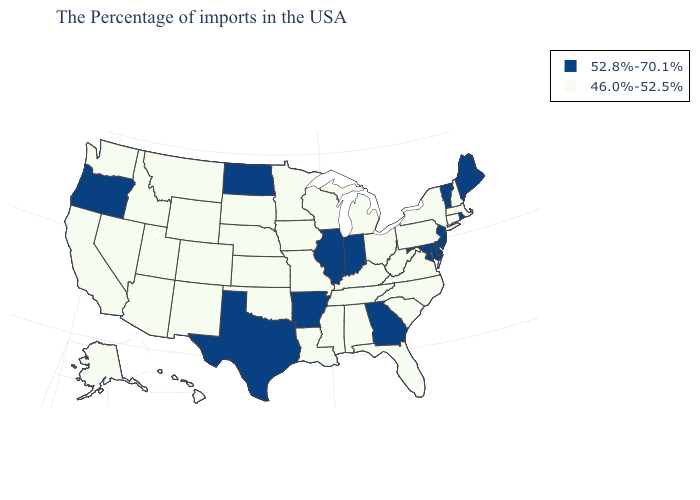Does Illinois have the highest value in the MidWest?
Give a very brief answer. Yes. Does Oregon have the lowest value in the West?
Give a very brief answer. No. Does Illinois have the highest value in the MidWest?
Be succinct. Yes. Among the states that border Connecticut , does Massachusetts have the lowest value?
Give a very brief answer. Yes. What is the value of New Hampshire?
Keep it brief. 46.0%-52.5%. Name the states that have a value in the range 46.0%-52.5%?
Write a very short answer. Massachusetts, New Hampshire, Connecticut, New York, Pennsylvania, Virginia, North Carolina, South Carolina, West Virginia, Ohio, Florida, Michigan, Kentucky, Alabama, Tennessee, Wisconsin, Mississippi, Louisiana, Missouri, Minnesota, Iowa, Kansas, Nebraska, Oklahoma, South Dakota, Wyoming, Colorado, New Mexico, Utah, Montana, Arizona, Idaho, Nevada, California, Washington, Alaska, Hawaii. Name the states that have a value in the range 46.0%-52.5%?
Quick response, please. Massachusetts, New Hampshire, Connecticut, New York, Pennsylvania, Virginia, North Carolina, South Carolina, West Virginia, Ohio, Florida, Michigan, Kentucky, Alabama, Tennessee, Wisconsin, Mississippi, Louisiana, Missouri, Minnesota, Iowa, Kansas, Nebraska, Oklahoma, South Dakota, Wyoming, Colorado, New Mexico, Utah, Montana, Arizona, Idaho, Nevada, California, Washington, Alaska, Hawaii. Name the states that have a value in the range 52.8%-70.1%?
Short answer required. Maine, Rhode Island, Vermont, New Jersey, Delaware, Maryland, Georgia, Indiana, Illinois, Arkansas, Texas, North Dakota, Oregon. Name the states that have a value in the range 46.0%-52.5%?
Give a very brief answer. Massachusetts, New Hampshire, Connecticut, New York, Pennsylvania, Virginia, North Carolina, South Carolina, West Virginia, Ohio, Florida, Michigan, Kentucky, Alabama, Tennessee, Wisconsin, Mississippi, Louisiana, Missouri, Minnesota, Iowa, Kansas, Nebraska, Oklahoma, South Dakota, Wyoming, Colorado, New Mexico, Utah, Montana, Arizona, Idaho, Nevada, California, Washington, Alaska, Hawaii. Does South Carolina have a lower value than Connecticut?
Concise answer only. No. Is the legend a continuous bar?
Concise answer only. No. Does Illinois have the lowest value in the MidWest?
Give a very brief answer. No. What is the lowest value in the USA?
Quick response, please. 46.0%-52.5%. What is the highest value in states that border Washington?
Keep it brief. 52.8%-70.1%. What is the lowest value in states that border Delaware?
Keep it brief. 46.0%-52.5%. 